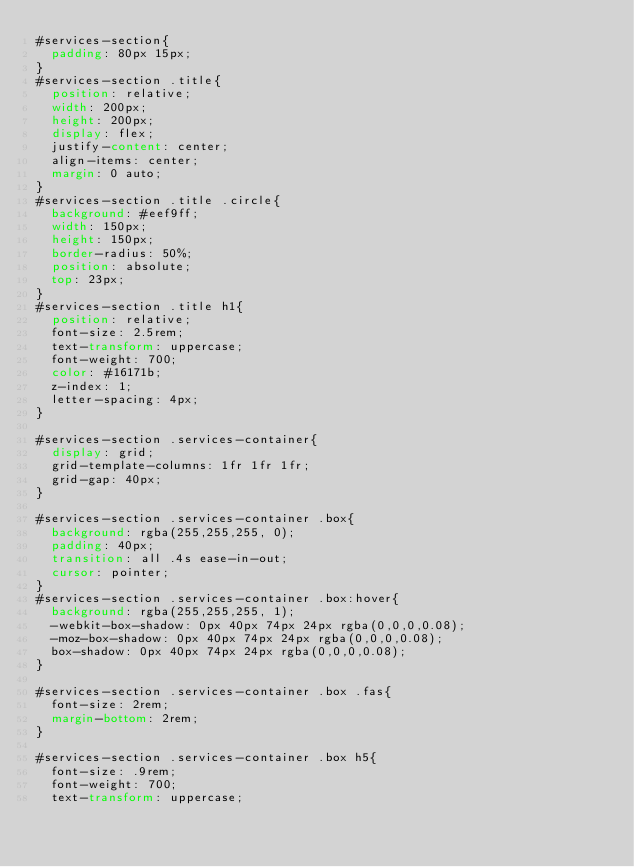Convert code to text. <code><loc_0><loc_0><loc_500><loc_500><_CSS_>#services-section{
  padding: 80px 15px;
}
#services-section .title{
  position: relative;
  width: 200px;
  height: 200px;
  display: flex;
  justify-content: center;
  align-items: center;
  margin: 0 auto;
}
#services-section .title .circle{
  background: #eef9ff;
  width: 150px;
  height: 150px;
  border-radius: 50%;
  position: absolute;
  top: 23px;
}
#services-section .title h1{
  position: relative;
  font-size: 2.5rem;
  text-transform: uppercase;
  font-weight: 700;
  color: #16171b;
  z-index: 1;
  letter-spacing: 4px;
}

#services-section .services-container{
  display: grid;
  grid-template-columns: 1fr 1fr 1fr;
  grid-gap: 40px;
}

#services-section .services-container .box{
  background: rgba(255,255,255, 0);
  padding: 40px;
  transition: all .4s ease-in-out;
  cursor: pointer;
}
#services-section .services-container .box:hover{
  background: rgba(255,255,255, 1);
  -webkit-box-shadow: 0px 40px 74px 24px rgba(0,0,0,0.08);
  -moz-box-shadow: 0px 40px 74px 24px rgba(0,0,0,0.08);
  box-shadow: 0px 40px 74px 24px rgba(0,0,0,0.08);
}

#services-section .services-container .box .fas{
  font-size: 2rem;
  margin-bottom: 2rem;
}

#services-section .services-container .box h5{
  font-size: .9rem;
  font-weight: 700;
  text-transform: uppercase;</code> 